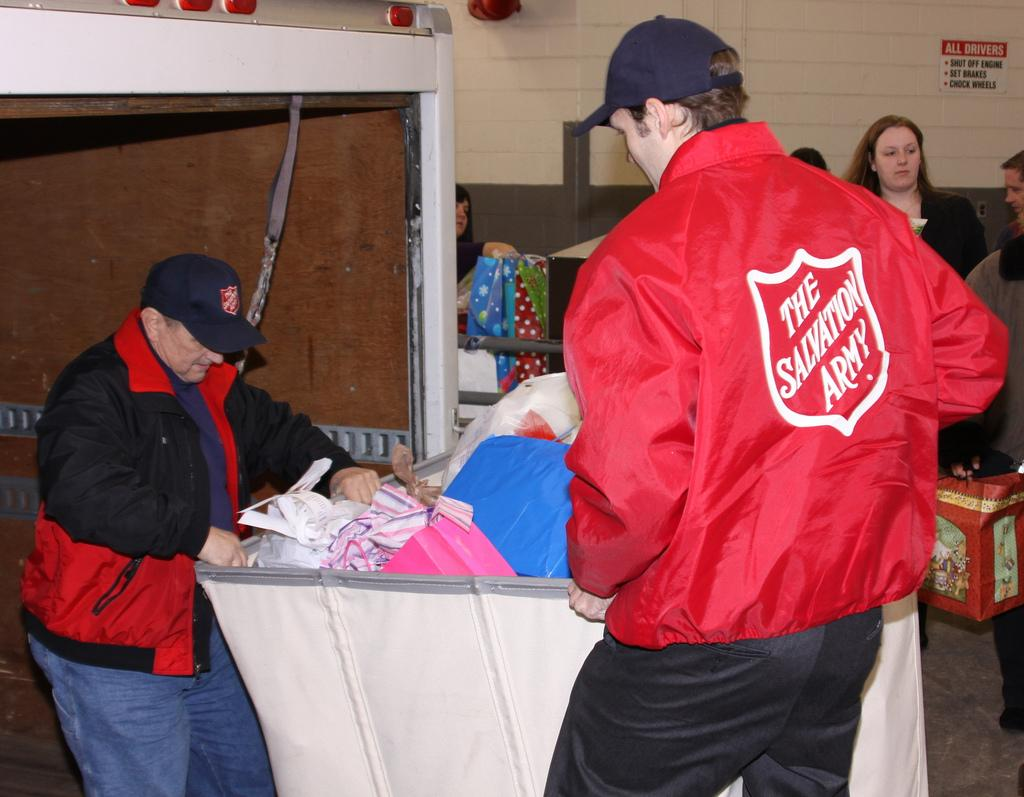<image>
Provide a brief description of the given image. Someone who works for the Salvation Army helps sort through a bin of donations. 